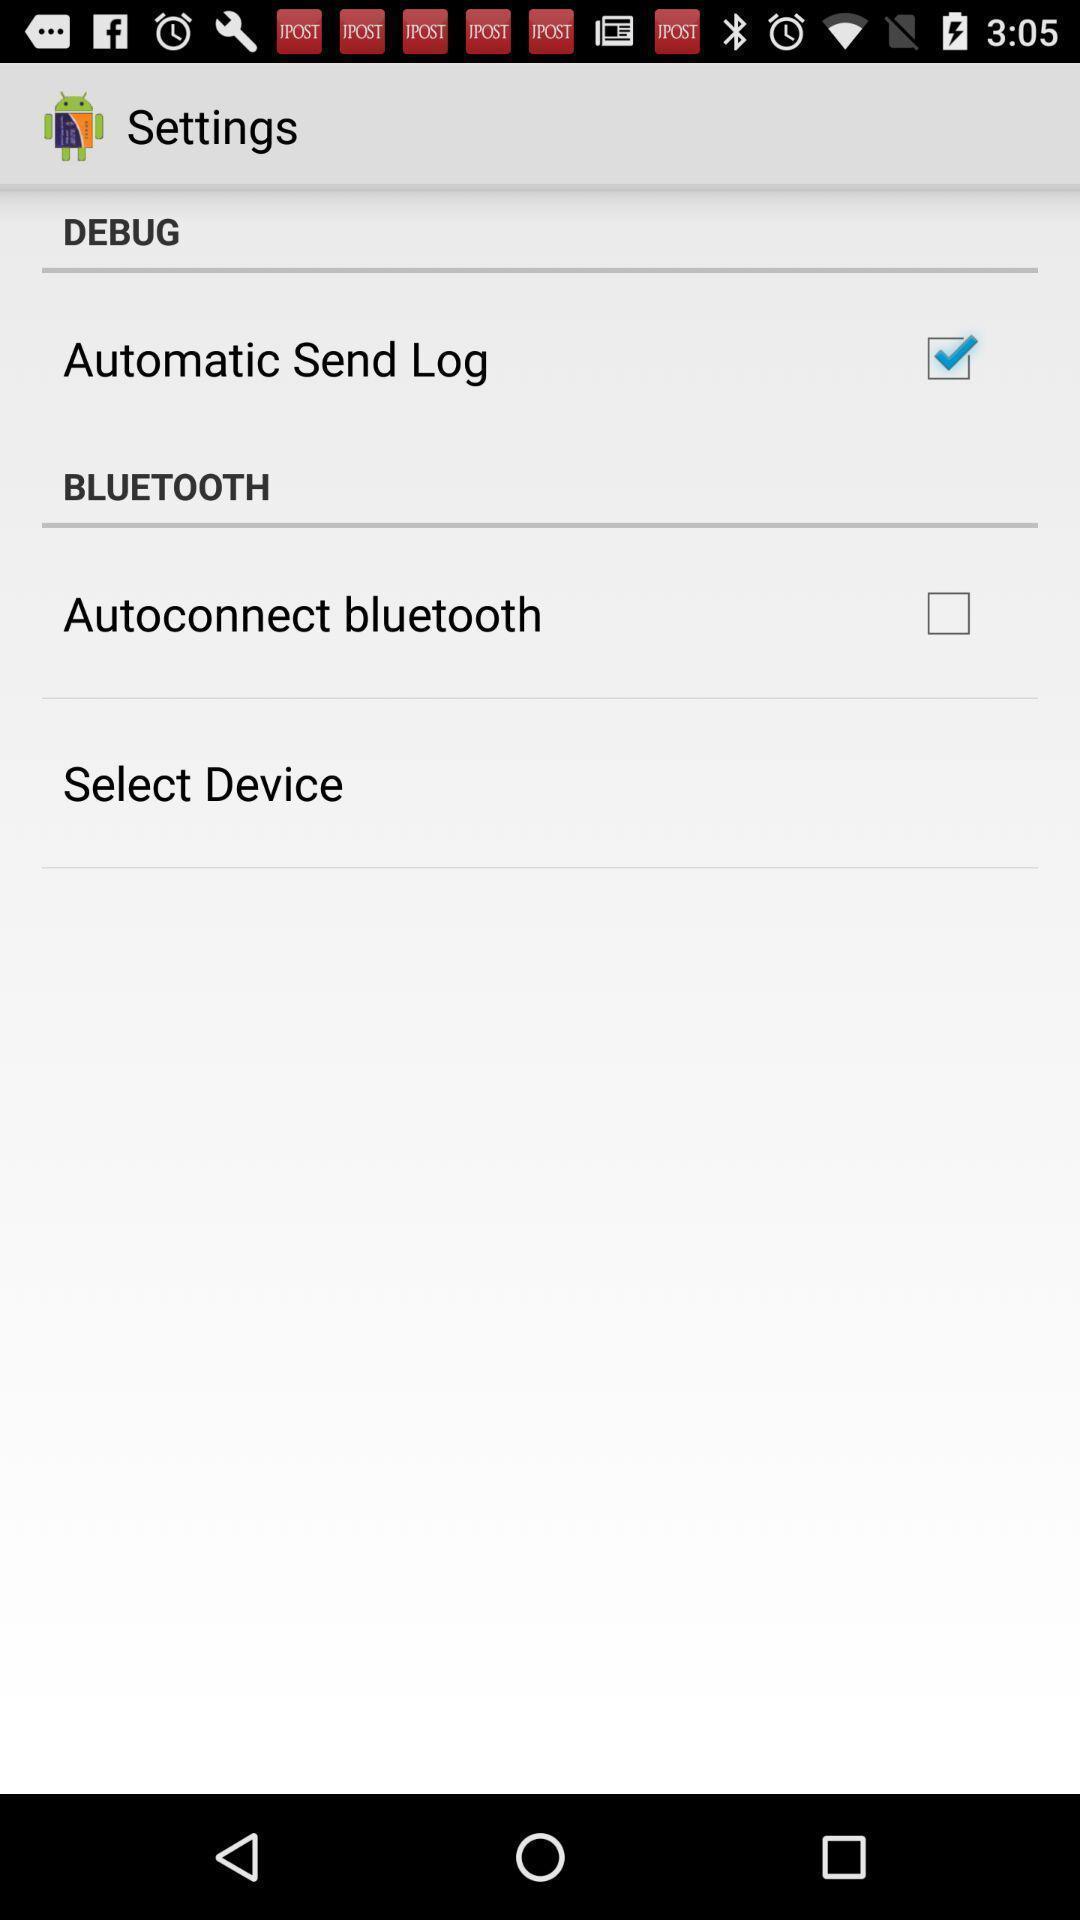Tell me about the visual elements in this screen capture. Screen about settings. 